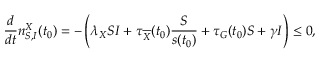<formula> <loc_0><loc_0><loc_500><loc_500>\frac { d } { d t } n _ { S , I } ^ { X } ( t _ { 0 } ) = - \left ( \lambda _ { X } S I + \tau _ { \overline { X } } ( t _ { 0 } ) \frac { S } { s ( t _ { 0 } ) } + \tau _ { G } ( t _ { 0 } ) S + \gamma I \right ) \leq 0 ,</formula> 